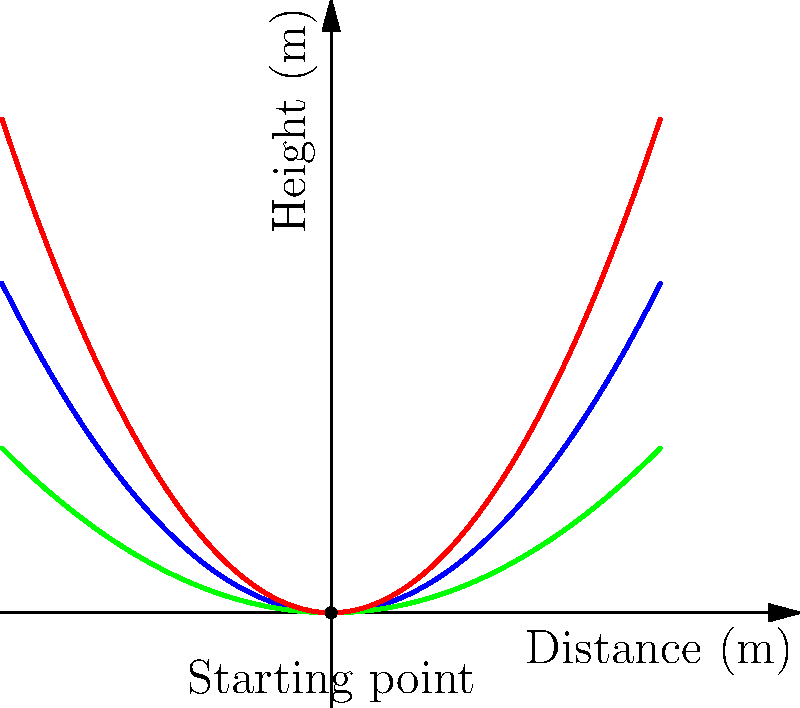Given your experience with tennis and considering the effects of knee problems on your game, analyze the graph showing the trajectories of tennis balls hit with different spin rates. Which spin rate would you recommend for a player looking to reduce stress on their knees while maintaining an effective shot? To answer this question, we need to consider the following factors:

1. Ball trajectory: The graph shows three different trajectories corresponding to low, medium, and high spin rates.

2. Knee stress: Higher trajectories generally require more knee bend and explosive movement, which can increase stress on the knees.

3. Effectiveness of the shot: A balance between height and distance is needed for an effective tennis shot.

Analyzing the trajectories:

a) Low spin (green curve):
   - Lowest overall height
   - Travels the farthest horizontally
   - Requires less upward force, potentially reducing knee stress

b) Medium spin (blue curve):
   - Moderate height and horizontal distance
   - Balanced trajectory

c) High spin (red curve):
   - Highest overall trajectory
   - Shortest horizontal distance
   - Requires more upward force, likely increasing knee stress

For a player with chronic knee problems:
- The low spin trajectory would be ideal as it minimizes the upward force required, thus reducing stress on the knees.
- It also provides the greatest horizontal distance, which can be advantageous in gameplay.
- The lower height might make it slightly easier for opponents to return, but this trade-off is worthwhile for knee health.

Therefore, the low spin rate would be the most suitable option for a player looking to reduce knee stress while maintaining an effective shot.
Answer: Low spin rate 